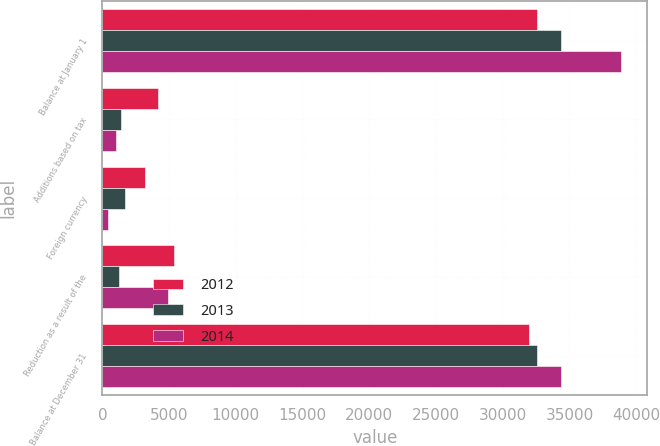<chart> <loc_0><loc_0><loc_500><loc_500><stacked_bar_chart><ecel><fcel>Balance at January 1<fcel>Additions based on tax<fcel>Foreign currency<fcel>Reduction as a result of the<fcel>Balance at December 31<nl><fcel>2012<fcel>32545<fcel>4187<fcel>3216<fcel>5349<fcel>31947<nl><fcel>2013<fcel>34337<fcel>1427<fcel>1681<fcel>1218<fcel>32545<nl><fcel>2014<fcel>38886<fcel>1037<fcel>439<fcel>4926<fcel>34337<nl></chart> 